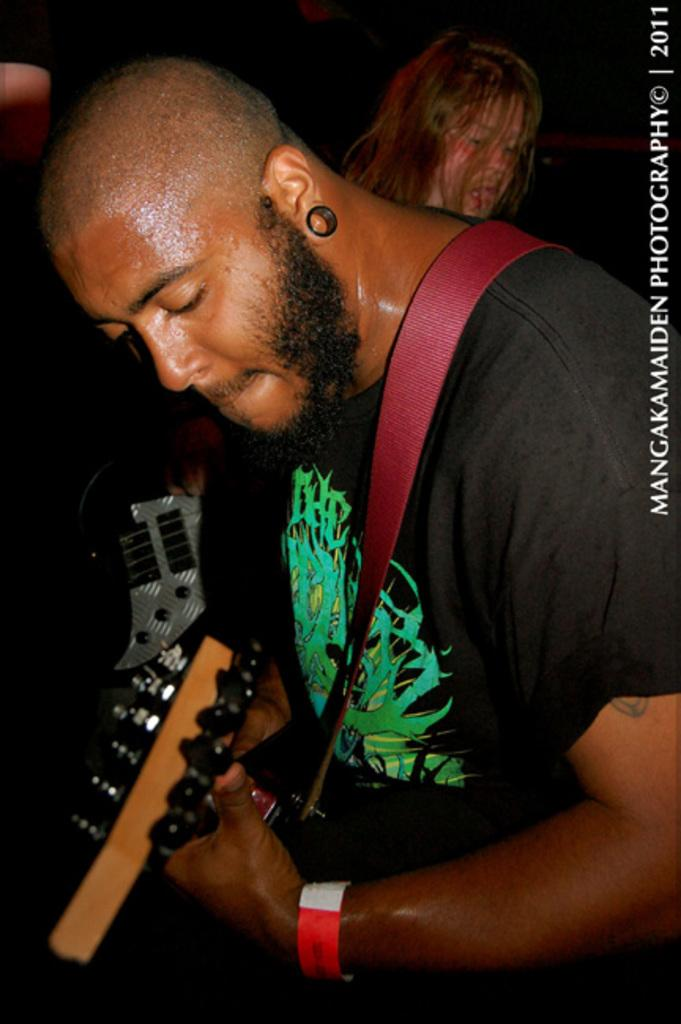What is the man in the image doing? The man is playing a guitar in the image. Can you describe the person in the background of the image? There is a person standing in the background of the image. What is written in the top right corner of the image? There is some text written in the top right corner of the image. What type of cheese is being used as a prop in the image? There is no cheese present in the image. How does the brick contribute to the overall composition of the image? There is no brick present in the image. 